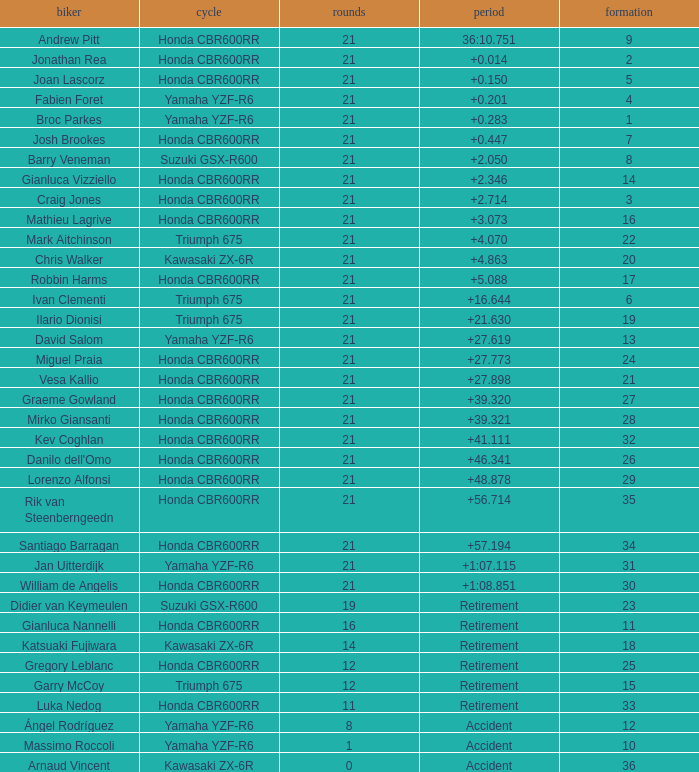What is the most number of laps run by Ilario Dionisi? 21.0. 